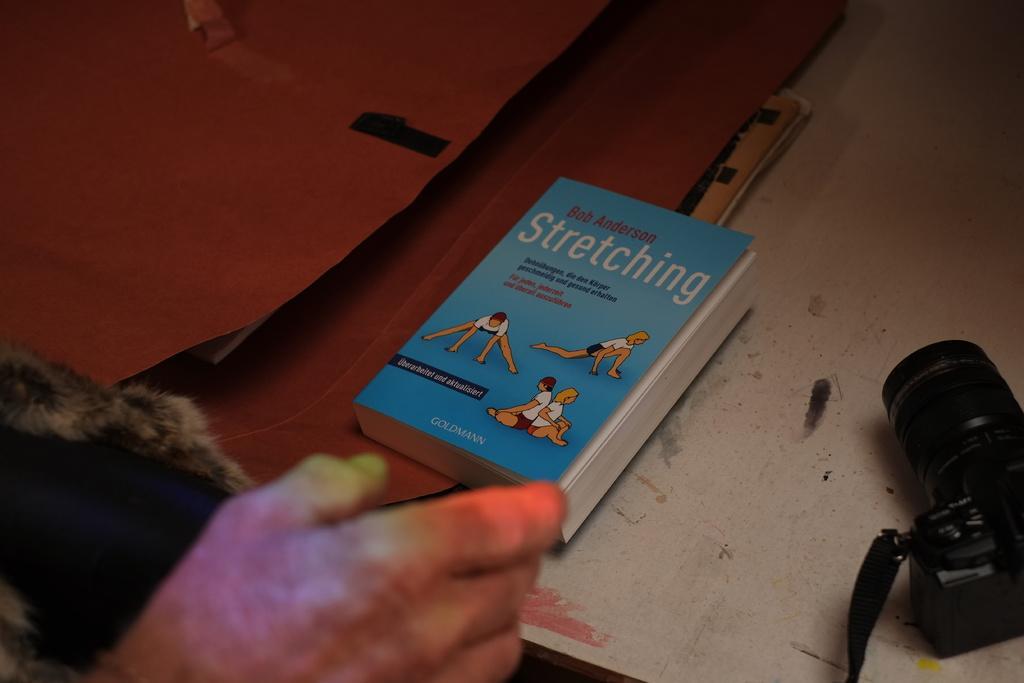In one or two sentences, can you explain what this image depicts? In this image we can see the hand of a person, in front of that there is a table. On the table there is a book, camera and few other objects. 